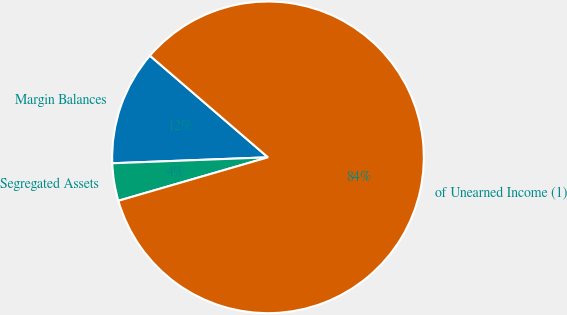Convert chart to OTSL. <chart><loc_0><loc_0><loc_500><loc_500><pie_chart><fcel>Margin Balances<fcel>Segregated Assets<fcel>of Unearned Income (1)<nl><fcel>11.92%<fcel>3.89%<fcel>84.19%<nl></chart> 